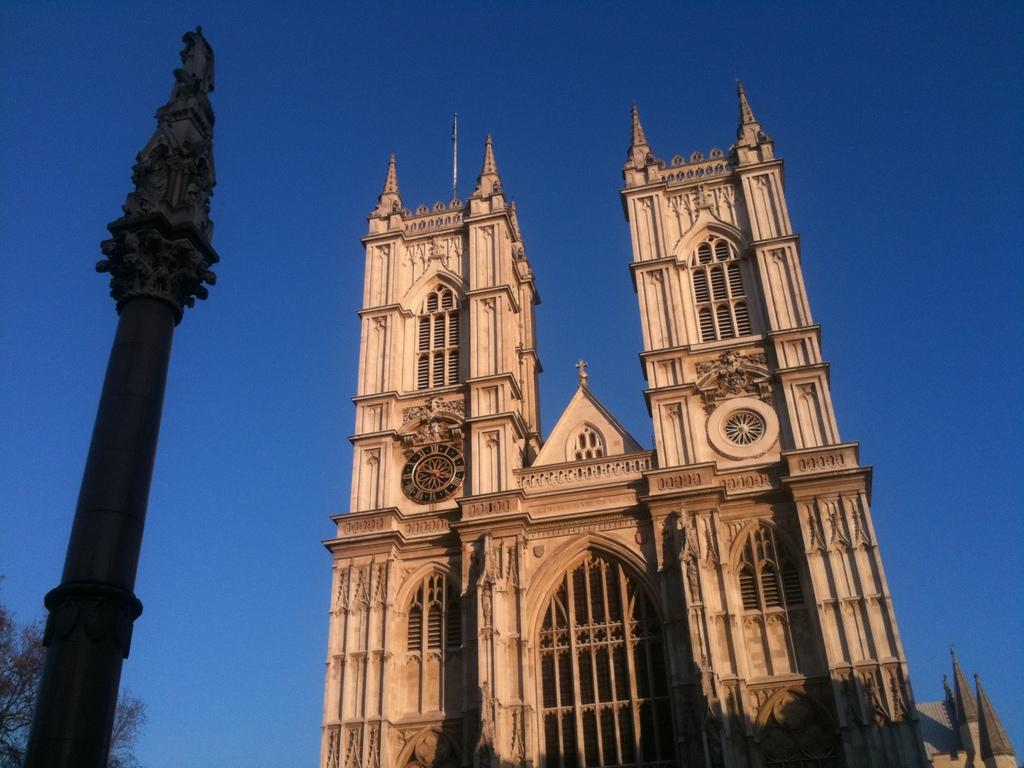What type of structure is the main subject of the image? There is a castle in the image. Where is the castle located in relation to the image? The castle is in the front of the image. What can be seen on the left side of the image? There is a pole on the left side of the image. What is visible in the background of the image? There is a tree in the background of the image. What feature is present on the castle? There is a clock on the castle. Can you see any children playing with a shoe and a kite in the image? There are no children, shoes, or kites present in the image. 